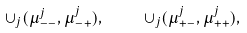Convert formula to latex. <formula><loc_0><loc_0><loc_500><loc_500>\cup _ { j } ( \mu _ { - - } ^ { j } , \mu _ { - + } ^ { j } ) , \quad \cup _ { j } ( \mu _ { + - } ^ { j } , \mu _ { + + } ^ { j } ) ,</formula> 